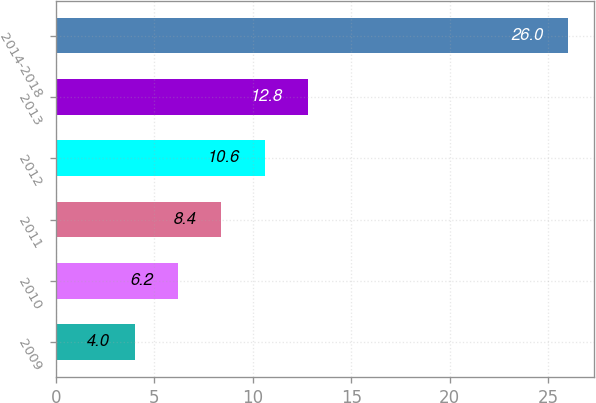<chart> <loc_0><loc_0><loc_500><loc_500><bar_chart><fcel>2009<fcel>2010<fcel>2011<fcel>2012<fcel>2013<fcel>2014-2018<nl><fcel>4<fcel>6.2<fcel>8.4<fcel>10.6<fcel>12.8<fcel>26<nl></chart> 